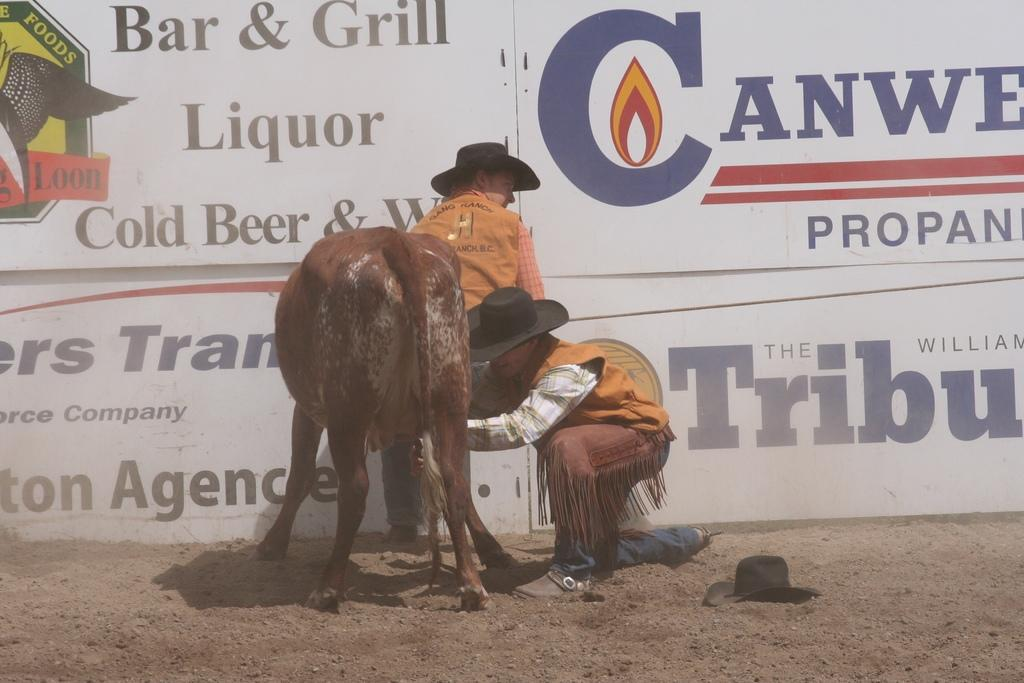How many people are in the image? There are two persons in the image. What are the people wearing on their heads? Both persons are wearing hats. What type of living creature is present in the image? There is an animal present in the image. Where is the animal located in the image? The animal is in the soil. What else is in the soil besides the animal? There is a hat in the soil. What can be seen in the background of the image? There are banners with text in the background of the image. What type of action is the mother performing with the tray in the image? There is no mother or tray present in the image. 